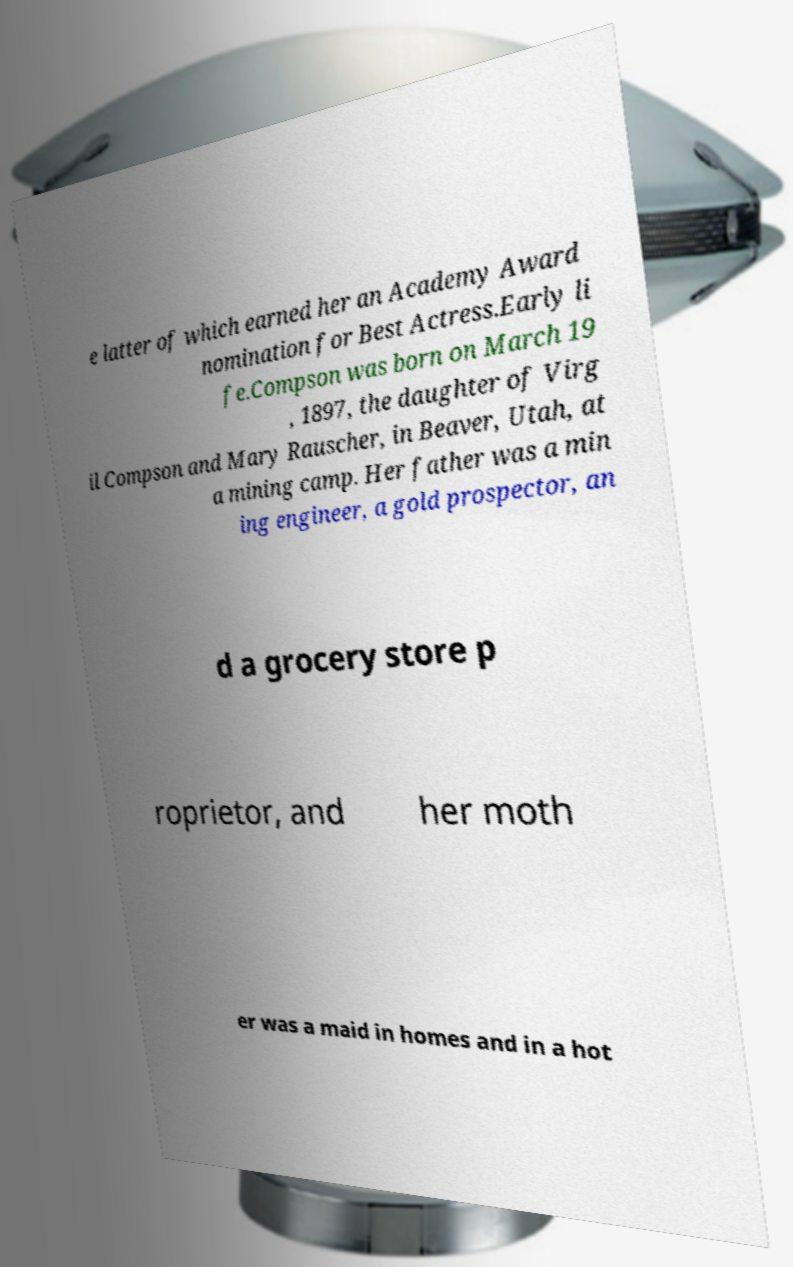Can you read and provide the text displayed in the image?This photo seems to have some interesting text. Can you extract and type it out for me? e latter of which earned her an Academy Award nomination for Best Actress.Early li fe.Compson was born on March 19 , 1897, the daughter of Virg il Compson and Mary Rauscher, in Beaver, Utah, at a mining camp. Her father was a min ing engineer, a gold prospector, an d a grocery store p roprietor, and her moth er was a maid in homes and in a hot 